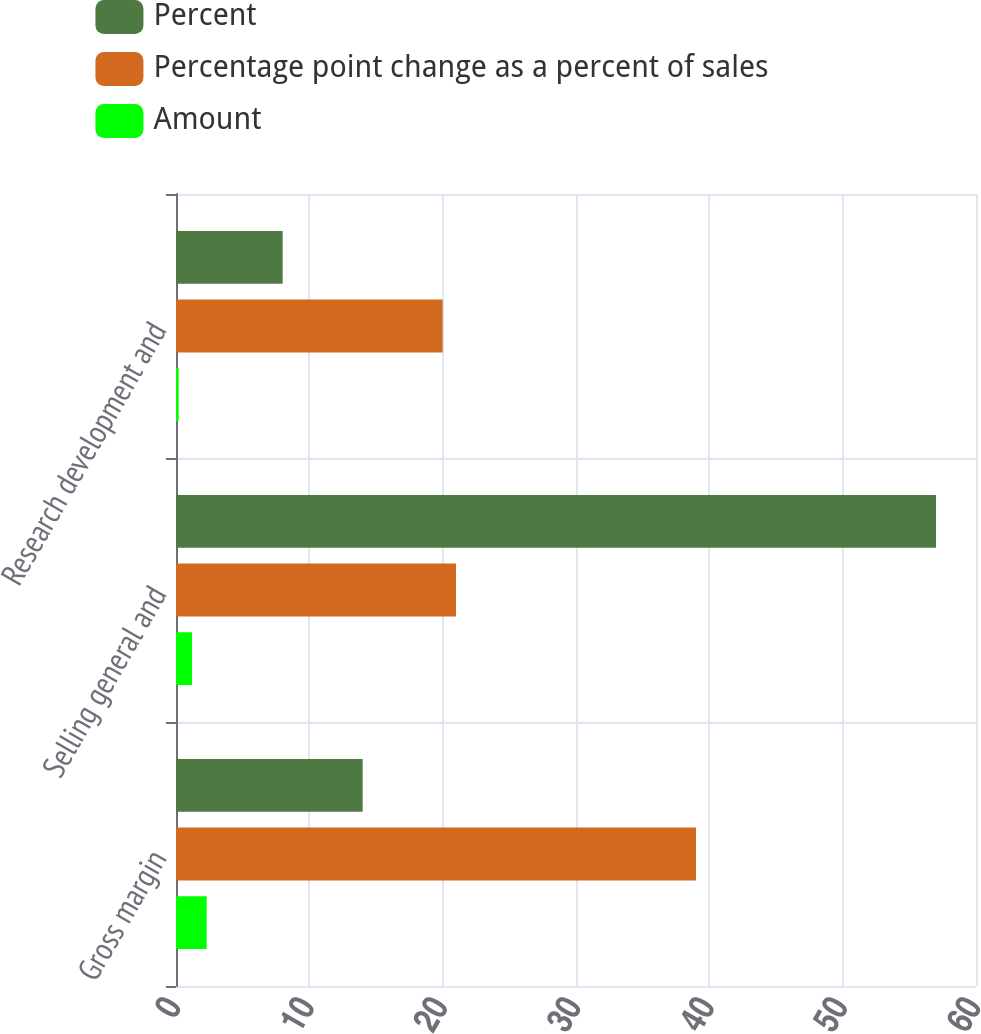<chart> <loc_0><loc_0><loc_500><loc_500><stacked_bar_chart><ecel><fcel>Gross margin<fcel>Selling general and<fcel>Research development and<nl><fcel>Percent<fcel>14<fcel>57<fcel>8<nl><fcel>Percentage point change as a percent of sales<fcel>39<fcel>21<fcel>20<nl><fcel>Amount<fcel>2.3<fcel>1.2<fcel>0.2<nl></chart> 